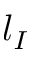<formula> <loc_0><loc_0><loc_500><loc_500>l _ { I }</formula> 